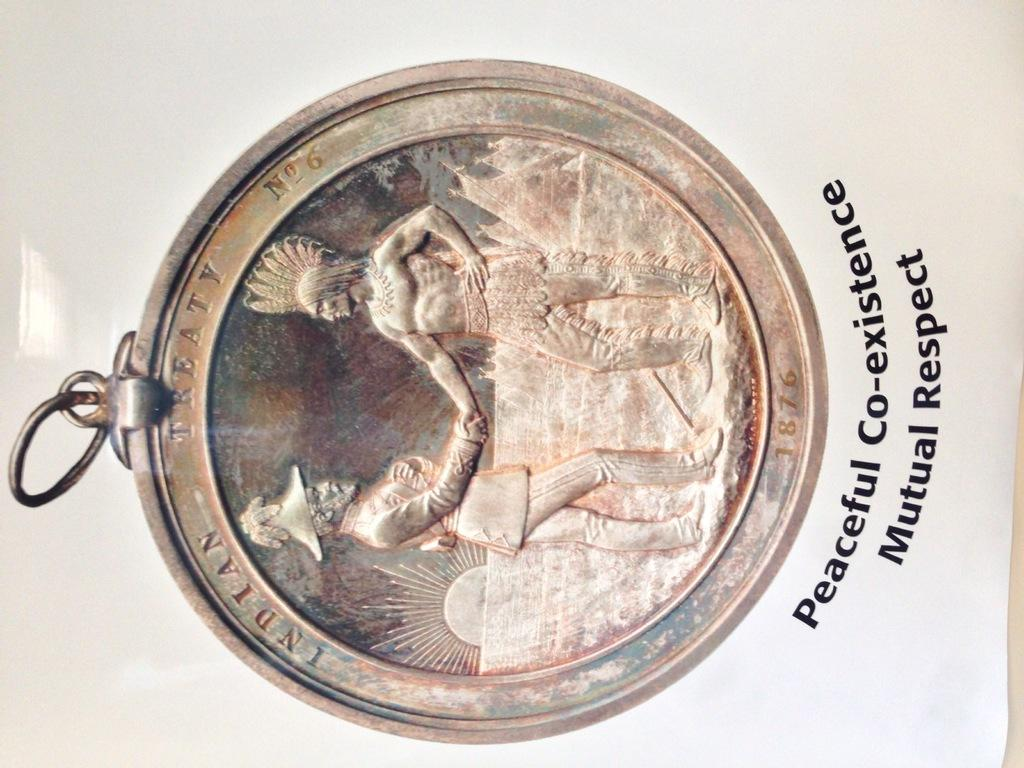<image>
Offer a succinct explanation of the picture presented. An aged bronze coin with 2 men on it that says Indian Treaty No 6. 